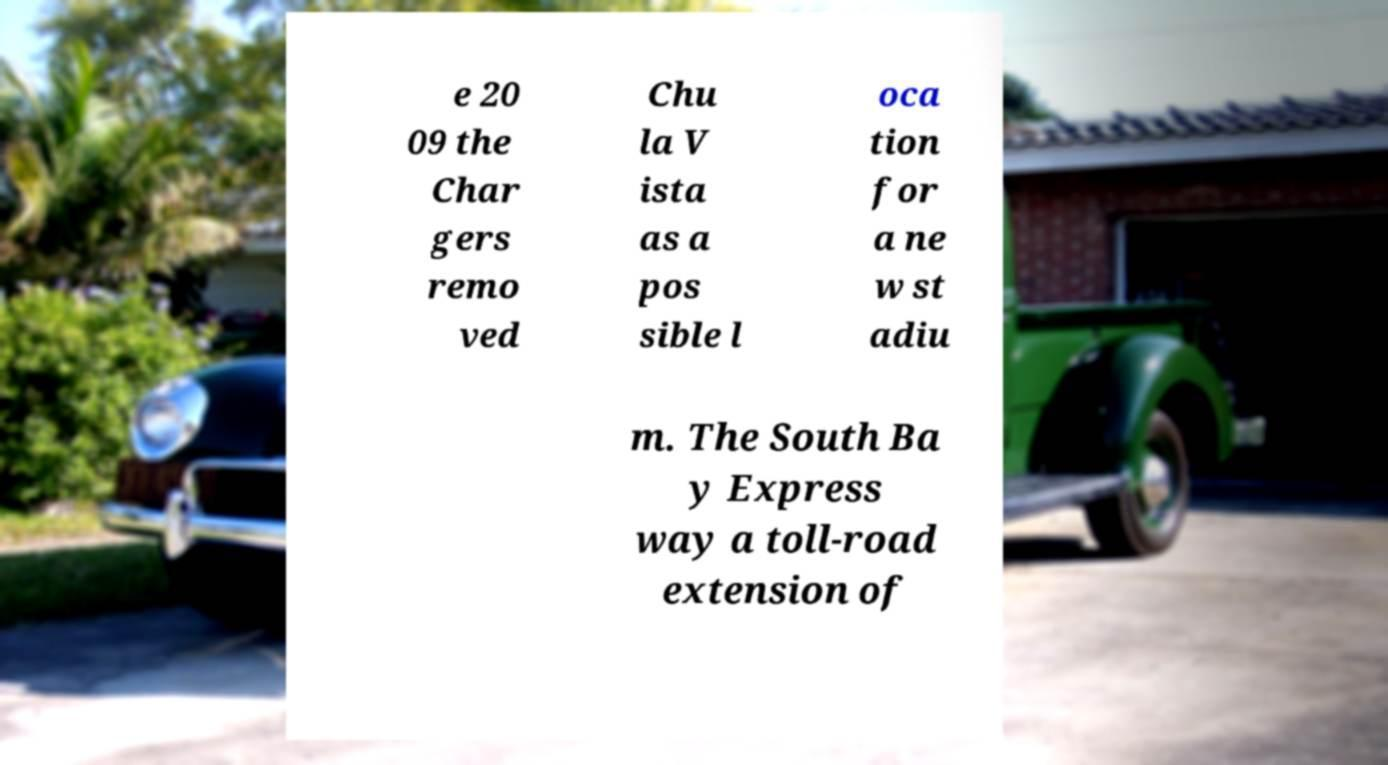What messages or text are displayed in this image? I need them in a readable, typed format. e 20 09 the Char gers remo ved Chu la V ista as a pos sible l oca tion for a ne w st adiu m. The South Ba y Express way a toll-road extension of 